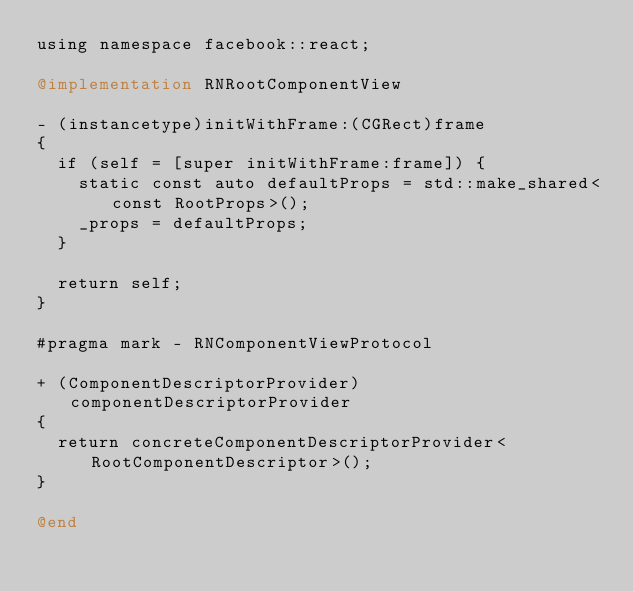Convert code to text. <code><loc_0><loc_0><loc_500><loc_500><_ObjectiveC_>using namespace facebook::react;

@implementation RNRootComponentView

- (instancetype)initWithFrame:(CGRect)frame
{
  if (self = [super initWithFrame:frame]) {
    static const auto defaultProps = std::make_shared<const RootProps>();
    _props = defaultProps;
  }

  return self;
}

#pragma mark - RNComponentViewProtocol

+ (ComponentDescriptorProvider)componentDescriptorProvider
{
  return concreteComponentDescriptorProvider<RootComponentDescriptor>();
}

@end
</code> 